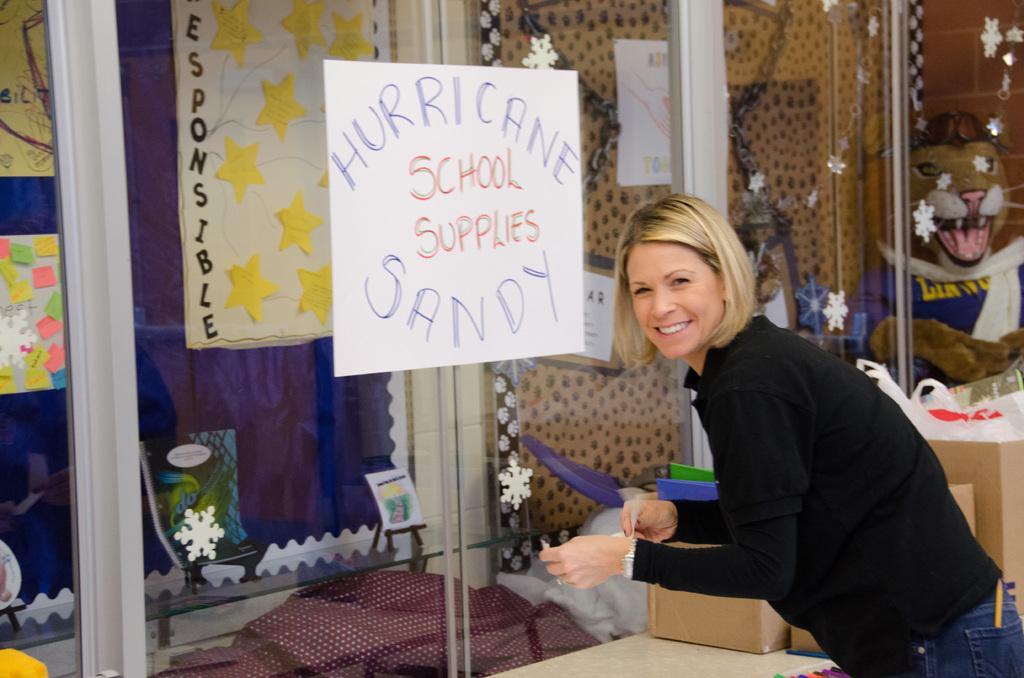Describe this image in one or two sentences. In this image, we can see a lady standing and smiling and there are posters placed on the glassdoor and we can see many stickers. At the bottom, we can see some boxes. 